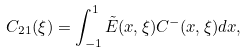Convert formula to latex. <formula><loc_0><loc_0><loc_500><loc_500>C _ { 2 1 } ( \xi ) = \int _ { - 1 } ^ { 1 } \tilde { E } ( x , \xi ) C ^ { - } ( x , \xi ) d x ,</formula> 